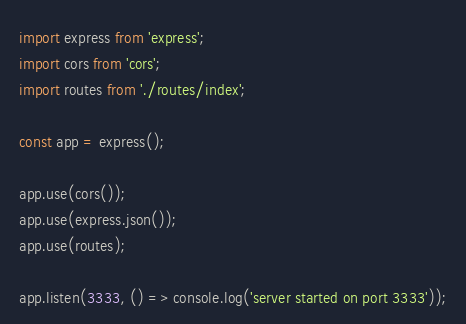<code> <loc_0><loc_0><loc_500><loc_500><_TypeScript_>import express from 'express';
import cors from 'cors';
import routes from './routes/index';

const app = express();

app.use(cors());
app.use(express.json());
app.use(routes);

app.listen(3333, () => console.log('server started on port 3333'));
</code> 